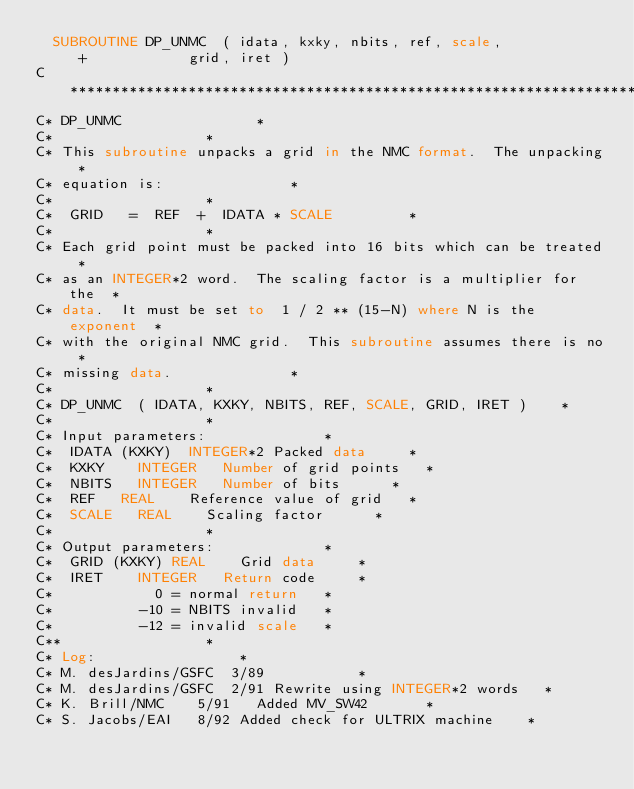<code> <loc_0><loc_0><loc_500><loc_500><_FORTRAN_>	SUBROUTINE DP_UNMC  ( idata, kxky, nbits, ref, scale,
     +			      grid, iret )
C************************************************************************
C* DP_UNMC								*
C*									*
C* This subroutine unpacks a grid in the NMC format.  The unpacking	*
C* equation is:								*
C*									*
C*	GRID   =  REF  +  IDATA * SCALE					*
C*									*
C* Each grid point must be packed into 16 bits which can be treated	*
C* as an INTEGER*2 word.  The scaling factor is a multiplier for the	*
C* data.  It must be set to  1 / 2 ** (15-N) where N is the exponent	*
C* with the original NMC grid.  This subroutine assumes there is no	*
C* missing data.							*
C*									*
C* DP_UNMC  ( IDATA, KXKY, NBITS, REF, SCALE, GRID, IRET )		*
C*									*
C* Input parameters:							*
C*	IDATA (KXKY)	INTEGER*2	Packed data			*
C*	KXKY		INTEGER		Number of grid points		*
C*	NBITS		INTEGER		Number of bits			*
C*	REF		REAL		Reference value of grid		*
C*	SCALE		REAL		Scaling factor			*
C*									*
C* Output parameters:							*
C*	GRID (KXKY)	REAL		Grid data			*
C*	IRET		INTEGER		Return code			*
C*					  0 = normal return		*
C*					-10 = NBITS invalid		*
C*					-12 = invalid scale		*
C**									*
C* Log:									*
C* M. desJardins/GSFC	 3/89						*
C* M. desJardins/GSFC	 2/91	Rewrite using INTEGER*2 words		*
C* K. Brill/NMC		 5/91   Added MV_SW42				*
C* S. Jacobs/EAI	 8/92	Added check for ULTRIX machine		*</code> 